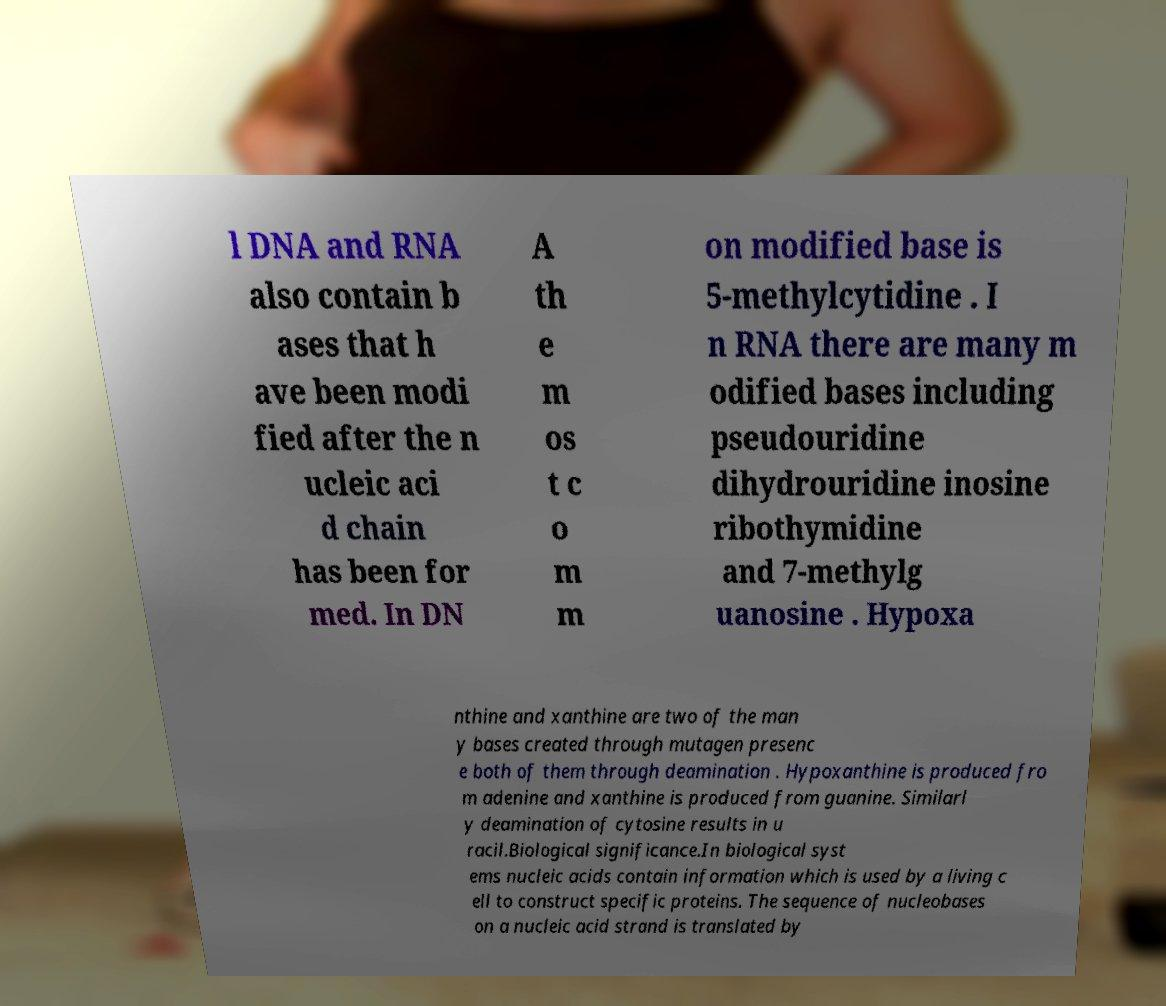Please read and relay the text visible in this image. What does it say? l DNA and RNA also contain b ases that h ave been modi fied after the n ucleic aci d chain has been for med. In DN A th e m os t c o m m on modified base is 5-methylcytidine . I n RNA there are many m odified bases including pseudouridine dihydrouridine inosine ribothymidine and 7-methylg uanosine . Hypoxa nthine and xanthine are two of the man y bases created through mutagen presenc e both of them through deamination . Hypoxanthine is produced fro m adenine and xanthine is produced from guanine. Similarl y deamination of cytosine results in u racil.Biological significance.In biological syst ems nucleic acids contain information which is used by a living c ell to construct specific proteins. The sequence of nucleobases on a nucleic acid strand is translated by 